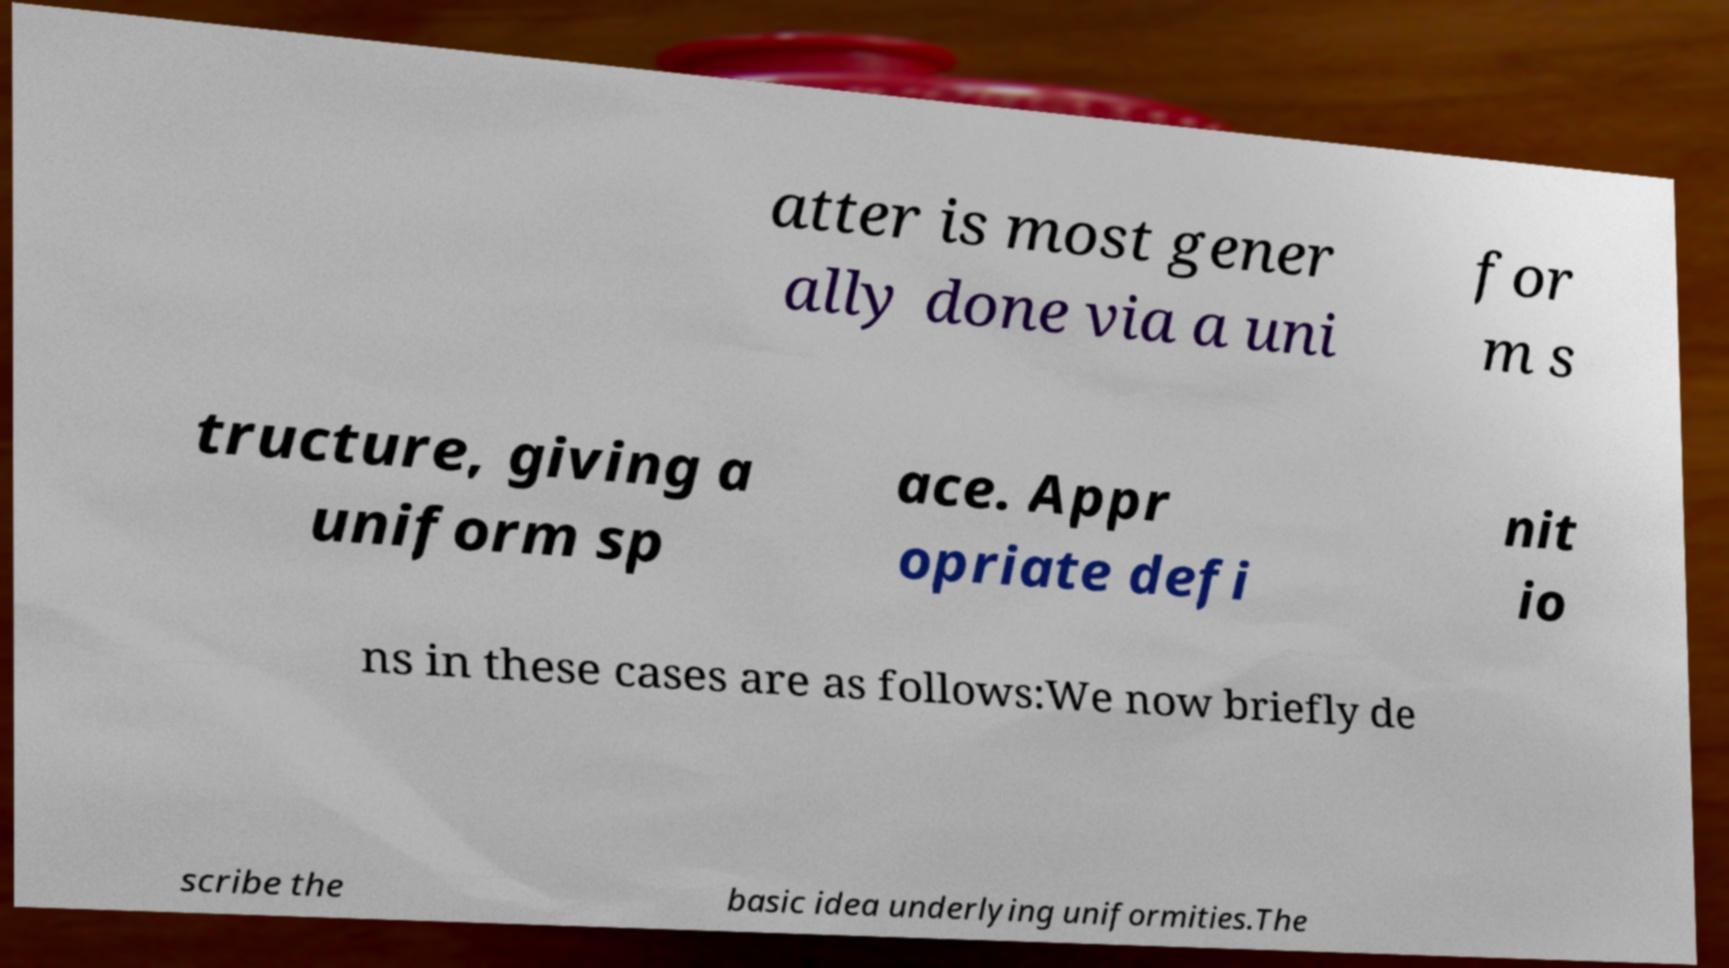Please identify and transcribe the text found in this image. atter is most gener ally done via a uni for m s tructure, giving a uniform sp ace. Appr opriate defi nit io ns in these cases are as follows:We now briefly de scribe the basic idea underlying uniformities.The 